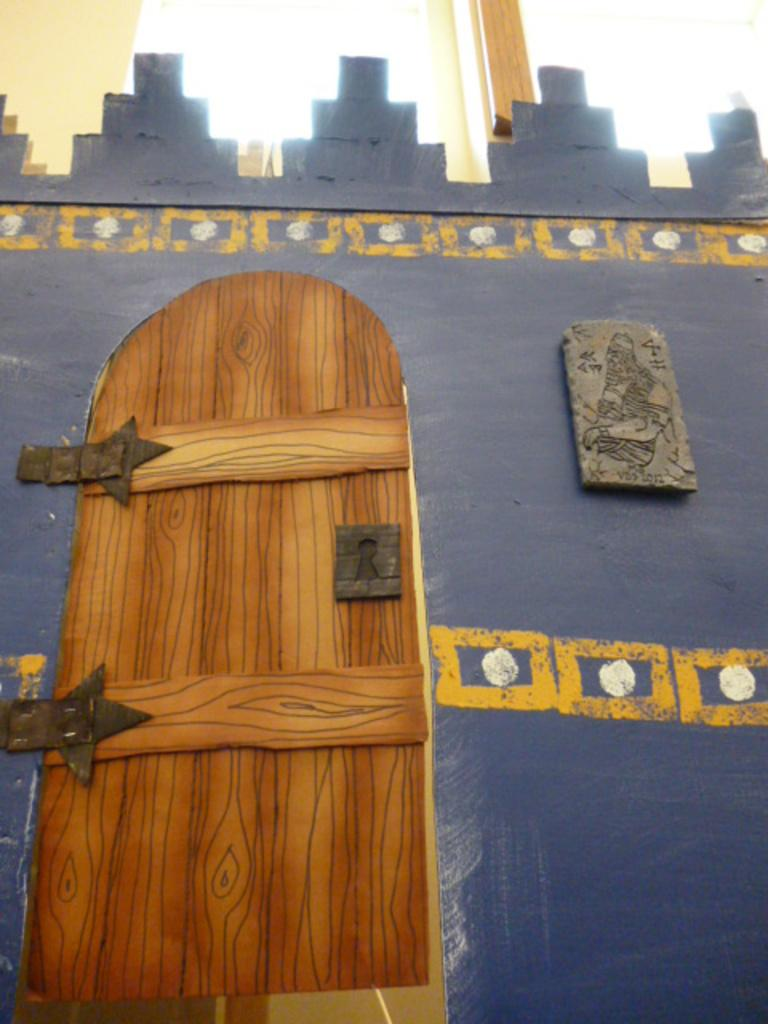What is located in the foreground of the image? There is a cardboard sheet in the foreground of the image. What is depicted on the cardboard sheet? The cardboard sheet is painted like a door and a wall. What can be seen in the background of the image? There is a wall in the background of the image. What object is on top of the wall in the background? It appears that there is a glass-like object on top of the wall in the background. What type of clam is being served for breakfast in the image? There is no clam or breakfast depicted in the image; it features a painted cardboard sheet and a wall in the background. Can you see a rabbit hiding behind the wall in the image? There is no rabbit present in the image; it only shows a cardboard sheet painted like a door and a wall, and a wall in the background with a glass-like object on top. 